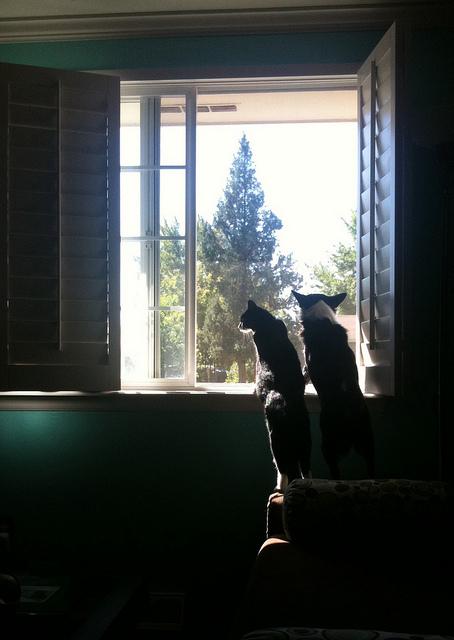Is the room dark?
Be succinct. Yes. Is there any cats in the photo?
Write a very short answer. Yes. What is looking out the window?
Keep it brief. Dog and cat. Are there clouds in the sky?
Keep it brief. No. Who owns the cats?
Keep it brief. Woman. What are the animals doing?
Give a very brief answer. Looking out window. Is the animal looking at the camera?
Give a very brief answer. No. 